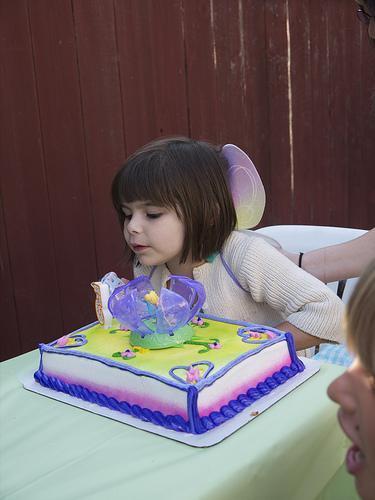How many children are present?
Give a very brief answer. 2. 